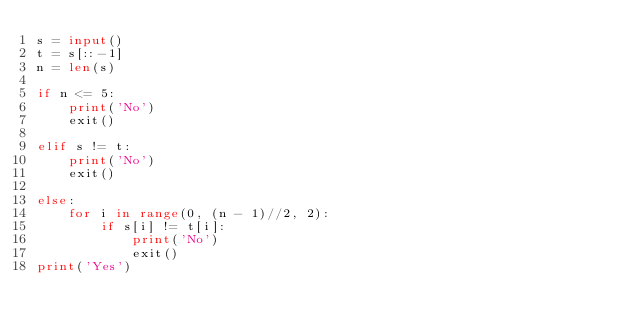Convert code to text. <code><loc_0><loc_0><loc_500><loc_500><_Python_>s = input()
t = s[::-1]
n = len(s)

if n <= 5:
    print('No')
    exit()
    
elif s != t:
    print('No')
    exit()

else:
    for i in range(0, (n - 1)//2, 2):
        if s[i] != t[i]:
            print('No')
            exit()
print('Yes')</code> 